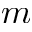Convert formula to latex. <formula><loc_0><loc_0><loc_500><loc_500>m</formula> 